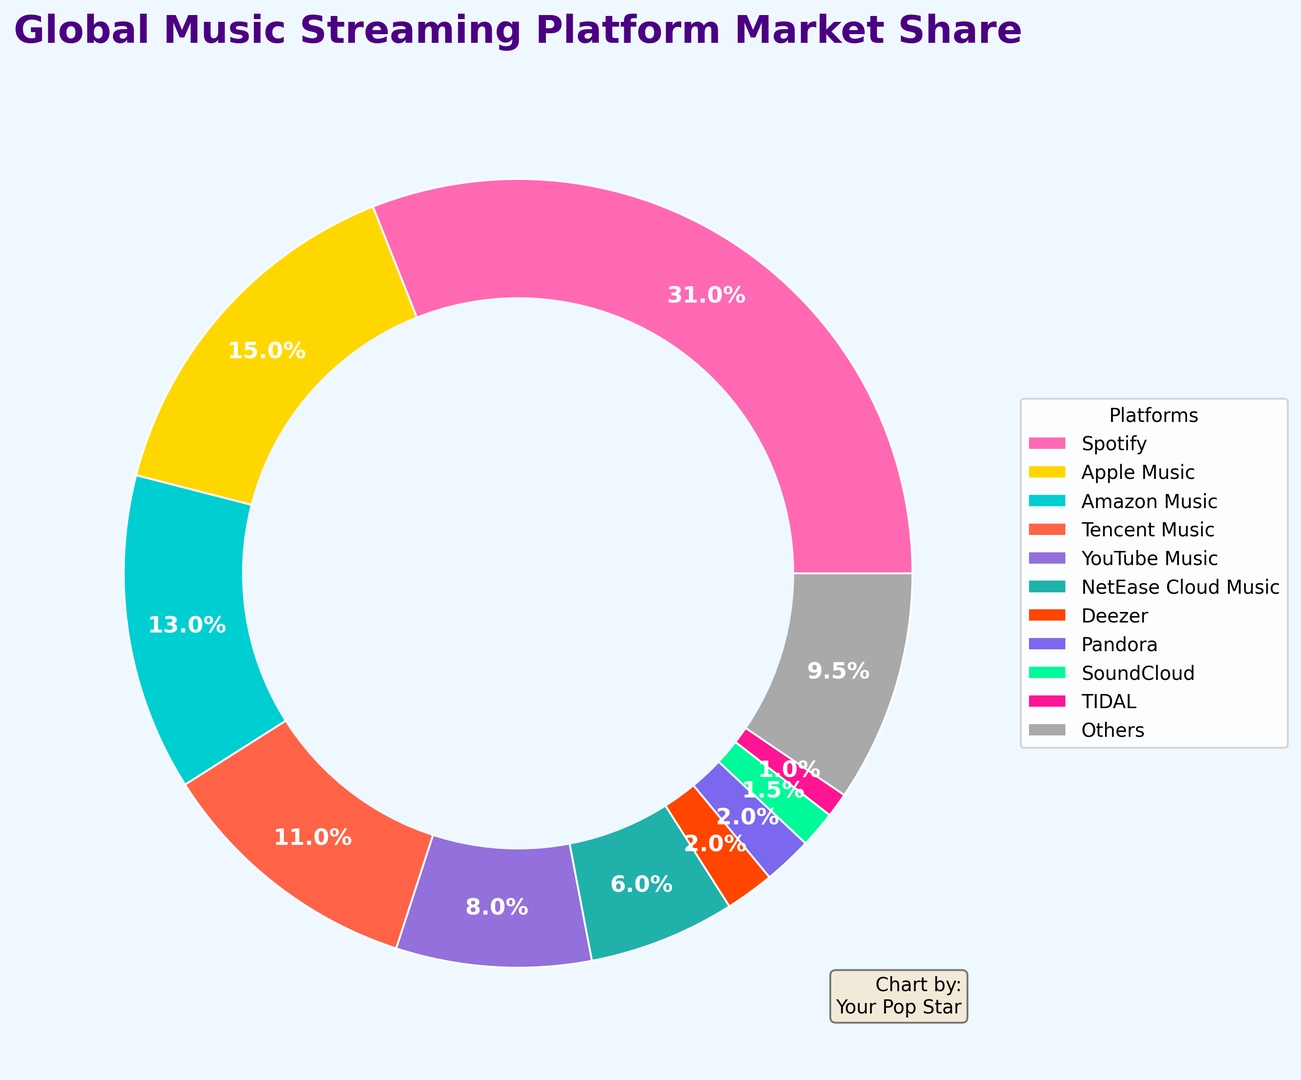What is the market share percentage of Spotify? The market share percentage is written inside the section of the chart that represents Spotify.
Answer: 31% Which platform has the smallest market share? Look for the smallest segment on the ring chart and check its label.
Answer: TIDAL How much larger is Spotify's market share compared to Apple Music's? Subtract Apple Music's market share from Spotify's market share (31% - 15%).
Answer: 16% What's the total market share of YouTube Music and NetEase Cloud Music combined? Add the market shares of YouTube Music (8%) and NetEase Cloud Music (6%).
Answer: 14% Is Amazon Music's market share greater than Tencent Music's? Compare the market share percentages of Amazon Music (13%) and Tencent Music (11%).
Answer: Yes What are the colors representing Apple Music and SoundCloud? Identify the segments for Apple Music and SoundCloud and describe their colors.
Answer: Apple Music: Gold, SoundCloud: Lime Green How much more market share do Others have compared to Pandora? Subtract Pandora's market share from Others' market share (9.5% - 2%).
Answer: 7.5% What is the percentage difference between Deezer and TIDAL's market shares? Subtract TIDAL’s market share from Deezer’s market share (2% - 1%).
Answer: 1% What is the second most popular music streaming platform? Identify the platform with the second-largest segment after Spotify.
Answer: Apple Music What is the combined market share of the three least popular platforms? Add the market shares of SoundCloud (1.5%), TIDAL (1%), and Deezer (2%).
Answer: 4.5% 